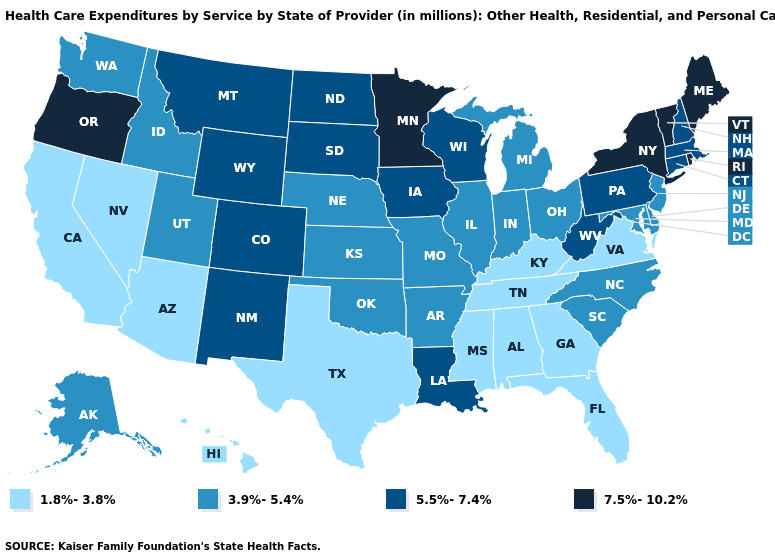Name the states that have a value in the range 7.5%-10.2%?
Be succinct. Maine, Minnesota, New York, Oregon, Rhode Island, Vermont. What is the value of Connecticut?
Answer briefly. 5.5%-7.4%. What is the value of North Dakota?
Concise answer only. 5.5%-7.4%. What is the value of Oklahoma?
Answer briefly. 3.9%-5.4%. Which states have the highest value in the USA?
Give a very brief answer. Maine, Minnesota, New York, Oregon, Rhode Island, Vermont. Name the states that have a value in the range 1.8%-3.8%?
Concise answer only. Alabama, Arizona, California, Florida, Georgia, Hawaii, Kentucky, Mississippi, Nevada, Tennessee, Texas, Virginia. What is the value of Vermont?
Write a very short answer. 7.5%-10.2%. Name the states that have a value in the range 1.8%-3.8%?
Write a very short answer. Alabama, Arizona, California, Florida, Georgia, Hawaii, Kentucky, Mississippi, Nevada, Tennessee, Texas, Virginia. Which states have the highest value in the USA?
Give a very brief answer. Maine, Minnesota, New York, Oregon, Rhode Island, Vermont. Does Maine have the highest value in the Northeast?
Write a very short answer. Yes. What is the value of Kansas?
Write a very short answer. 3.9%-5.4%. Does Minnesota have a lower value than Florida?
Concise answer only. No. What is the value of Idaho?
Write a very short answer. 3.9%-5.4%. What is the highest value in the MidWest ?
Keep it brief. 7.5%-10.2%. Which states hav the highest value in the MidWest?
Short answer required. Minnesota. 